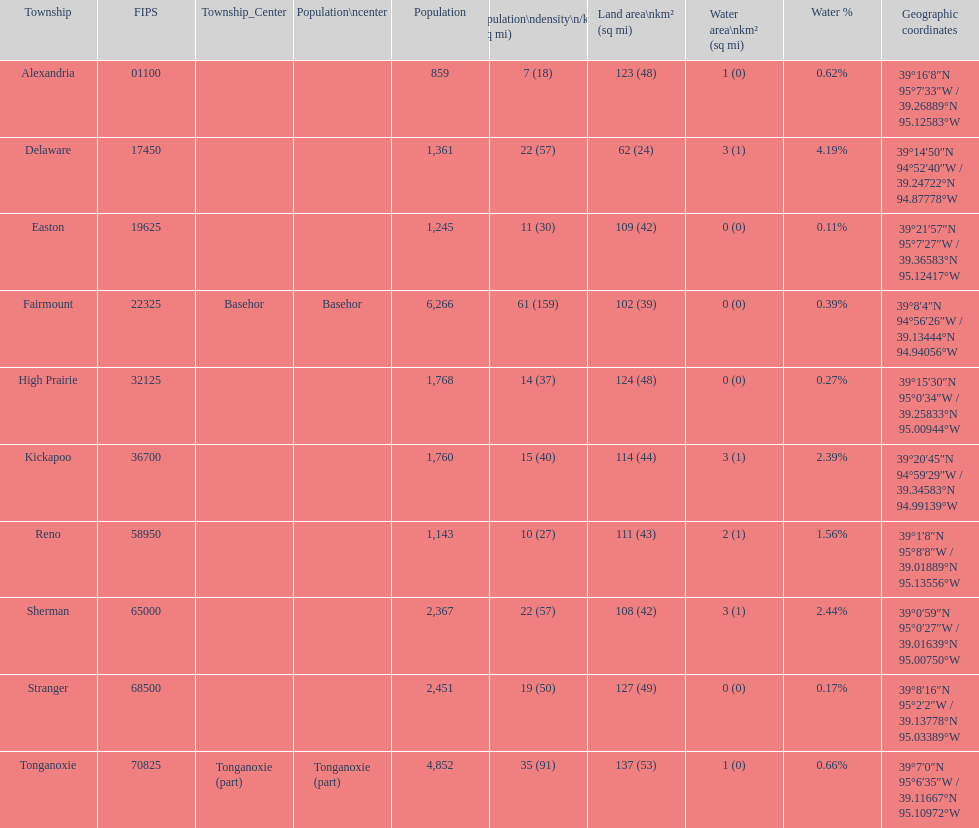What township has the most land area? Tonganoxie. 